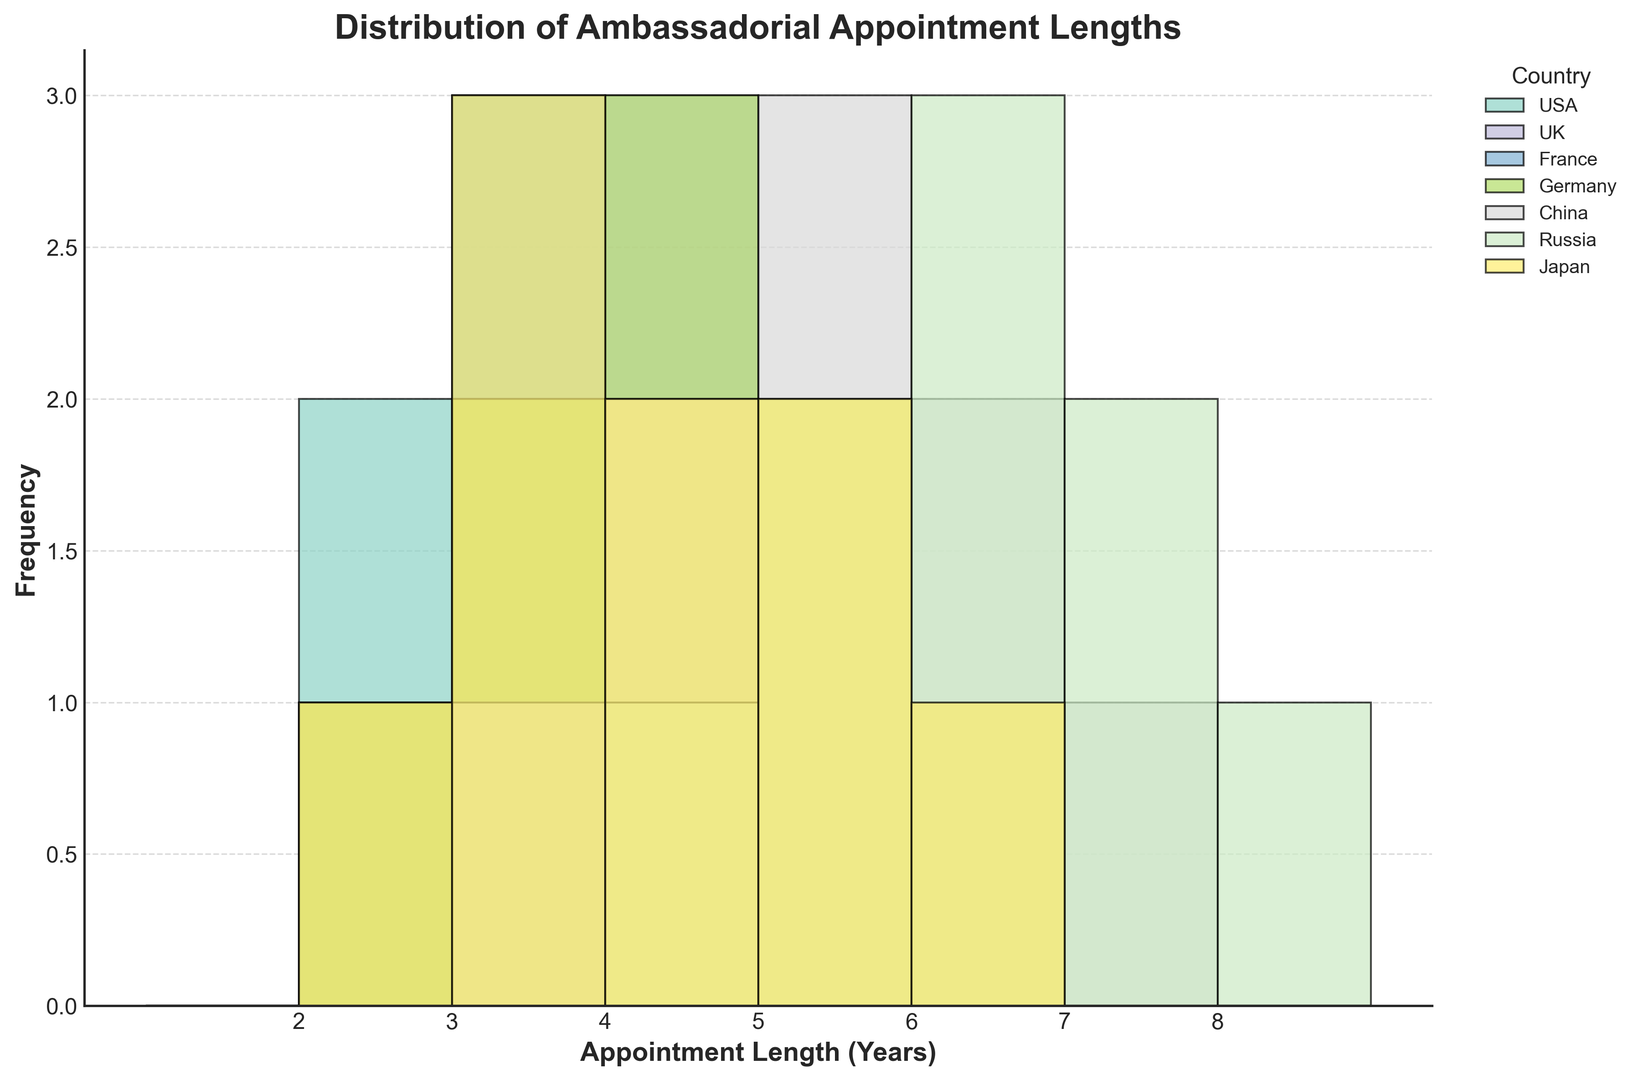Which country has the highest frequency in the 4-year appointment length category? The histogram shows the frequency of appointment lengths for each country. By locating the bar representing the 4-year appointment length and comparing the heights across the countries, we can see which one has the highest frequency.
Answer: UK and Germany Which country has the lowest maximum appointment length? The histogram includes the appointment lengths range (x-axis). By identifying the longest bar for each country along this range, we can conclude which country has the lowest maximum appointment length.
Answer: Japan What is the total number of 5-year appointments for all countries combined? To determine this, count the height of the 5-year bar for each country and then sum these values. For USA, it's 1; for UK, it's 2; for France, it's 2; for Germany, it's 2; for China, it's 3; for Russia, it's 2; for Japan, it's 2. Adding these: 1 + 2 + 2 + 2 + 3 + 2 + 2 = 14.
Answer: 14 Which country has the most diverse range of appointment lengths, and what is that range? Diversity in range can be determined by observing the width of the distribution of appointment lengths for each country. Range is calculated by subtracting the minimum length from the maximum length. By examining the histogram, Russia has the widest distribution from 2 to 8 years, which is a range of 6 years.
Answer: Russia, 6 years Which appointment length is the most frequent across all countries? Find the most common appointment length by looking at the combined heights of each duration bar across all countries. The appointment length of 4 years has the highest aggregate bar height.
Answer: 4 years How does the frequency of 3-year appointments in the USA compare to that in France? Locate the 3-year appointment bars for both countries in the histogram and compare their heights. USA has a frequency of 3 and France has a frequency of 3 as well.
Answer: Equal Which country’s distribution shows no appointments longer than 6 years? By looking at the histogram, the countries without bars extending past the 6-year mark are identified. Japan and Germany don’t have appointments longer than 6 years.
Answer: Japan and Germany Among all countries, which one has the highest frequency of 6-year appointments? To determine this, examine the height of the 6-year bars for each country. Russia has the highest frequency of 6-year appointments.
Answer: Russia 